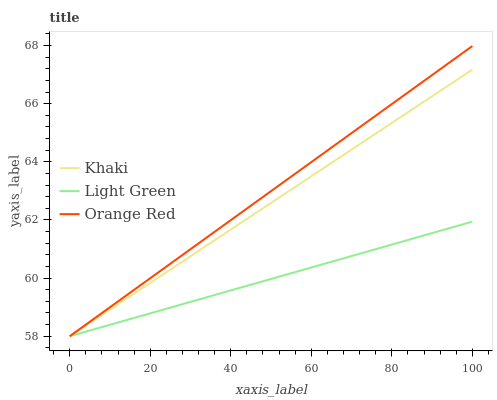Does Light Green have the minimum area under the curve?
Answer yes or no. Yes. Does Orange Red have the maximum area under the curve?
Answer yes or no. Yes. Does Orange Red have the minimum area under the curve?
Answer yes or no. No. Does Light Green have the maximum area under the curve?
Answer yes or no. No. Is Khaki the smoothest?
Answer yes or no. Yes. Is Light Green the roughest?
Answer yes or no. Yes. Is Orange Red the smoothest?
Answer yes or no. No. Is Orange Red the roughest?
Answer yes or no. No. Does Khaki have the lowest value?
Answer yes or no. Yes. Does Orange Red have the highest value?
Answer yes or no. Yes. Does Light Green have the highest value?
Answer yes or no. No. Does Orange Red intersect Light Green?
Answer yes or no. Yes. Is Orange Red less than Light Green?
Answer yes or no. No. Is Orange Red greater than Light Green?
Answer yes or no. No. 